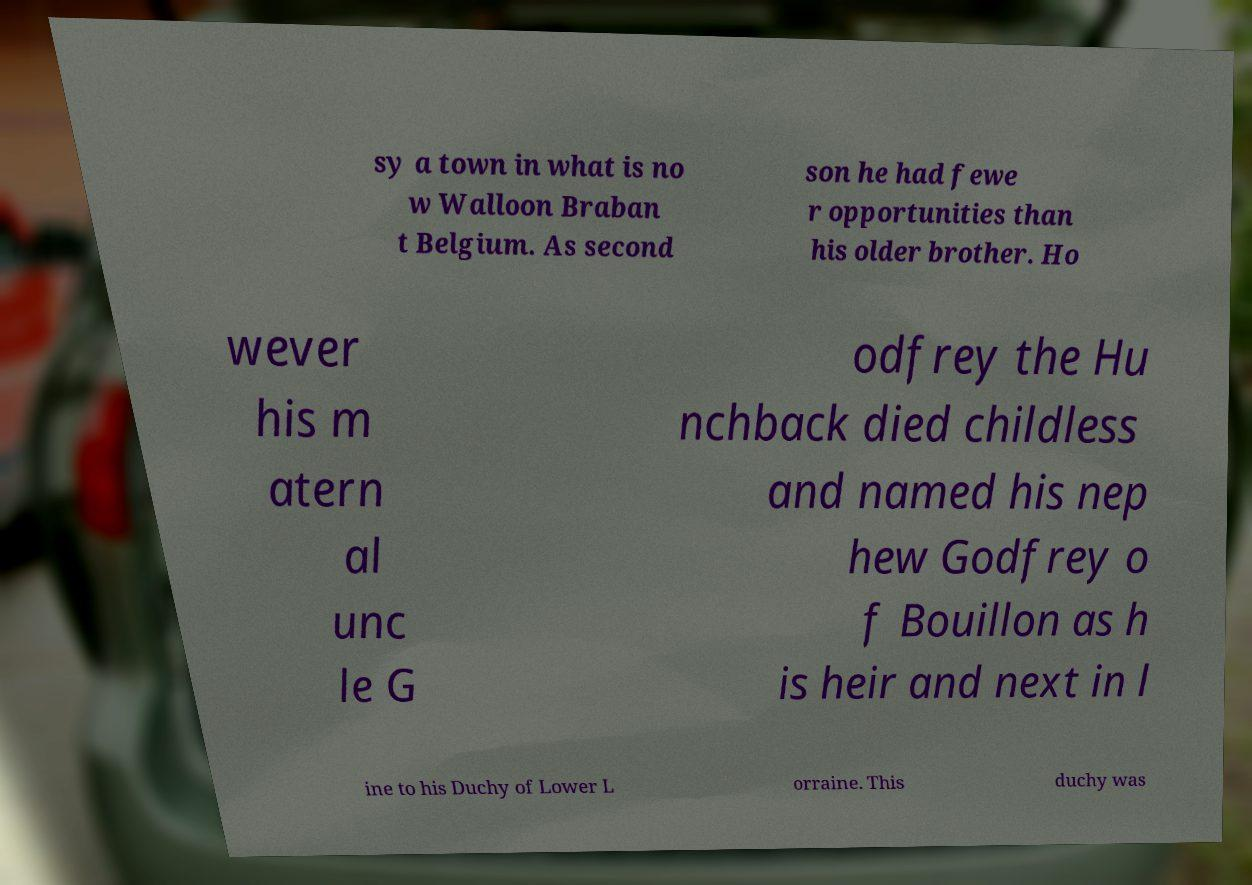For documentation purposes, I need the text within this image transcribed. Could you provide that? sy a town in what is no w Walloon Braban t Belgium. As second son he had fewe r opportunities than his older brother. Ho wever his m atern al unc le G odfrey the Hu nchback died childless and named his nep hew Godfrey o f Bouillon as h is heir and next in l ine to his Duchy of Lower L orraine. This duchy was 